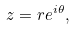<formula> <loc_0><loc_0><loc_500><loc_500>z = r e ^ { i \theta } ,</formula> 